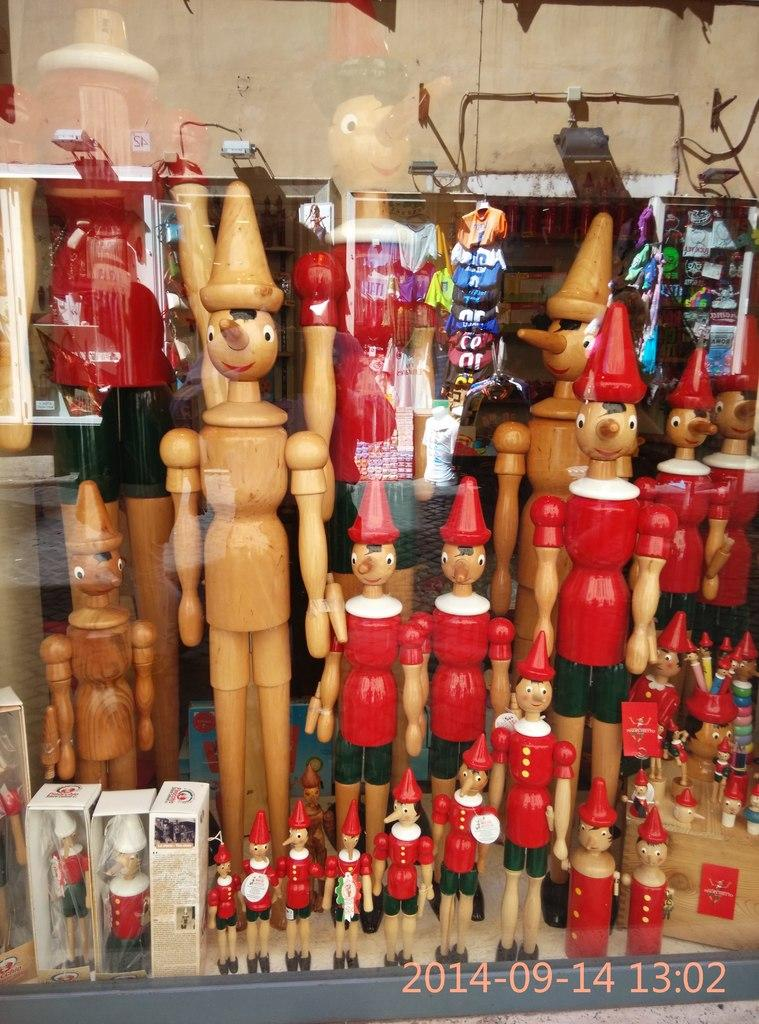What type of barrier is present in the image? There is a glass window in the image. What can be seen on the other side of the window? Toys and boxes are visible on the other side of the window. What is located at the top of the image? There is a well at the top of the image. Reasoning: Let' Let's think step by step in order to produce the conversation. We start by identifying the main barrier in the image, which is the glass window. Then, we describe what can be seen on the other side of the window, which includes toys and boxes. Finally, we mention the well located at the top of the image. Each question is designed to elicit a specific detail about the image that is known from the provided facts. Absurd Question/Answer: What type of pickle is being used to make a statement in the image? There is no pickle present in the image, nor is there any indication of a statement being made. 